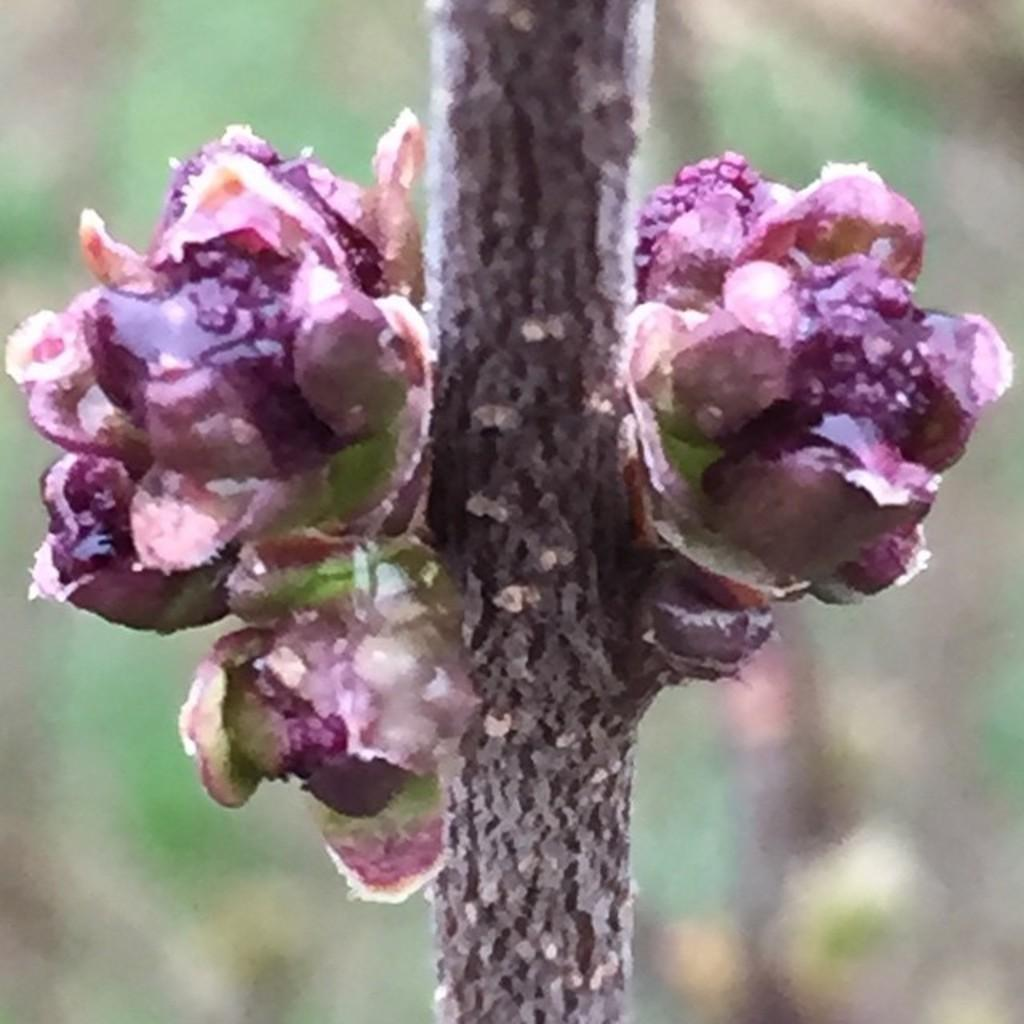What type of plants are visible in the image? There are flowers in the image. Can you describe the structure of the flowers? The flowers have stems. What can be observed about the background of the image? The background of the image has a blurred view. What type of boat can be seen carrying a parcel in the image? There is no boat or parcel present in the image; it features flowers with stems and a blurred background. 